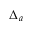Convert formula to latex. <formula><loc_0><loc_0><loc_500><loc_500>\Delta _ { a }</formula> 